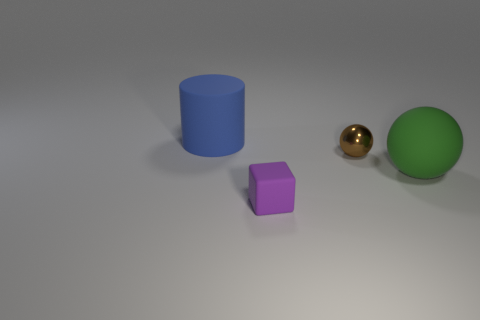Is the small object behind the small purple cube made of the same material as the big object that is left of the purple rubber thing?
Keep it short and to the point. No. How many objects are small things right of the small purple thing or rubber objects behind the purple block?
Make the answer very short. 3. What is the shape of the matte object that is left of the large green thing and in front of the large cylinder?
Your answer should be very brief. Cube. The thing that is the same size as the matte cylinder is what color?
Your answer should be compact. Green. There is a object behind the shiny ball; does it have the same size as the green object right of the small matte thing?
Your answer should be compact. Yes. There is a thing that is both right of the large blue thing and behind the rubber sphere; what is its material?
Keep it short and to the point. Metal. There is a thing that is in front of the big green rubber sphere; what is it made of?
Your answer should be very brief. Rubber. Is the blue thing the same shape as the small purple thing?
Keep it short and to the point. No. What number of other objects are the same shape as the large blue object?
Provide a short and direct response. 0. There is a big object right of the small rubber thing; what color is it?
Provide a short and direct response. Green. 